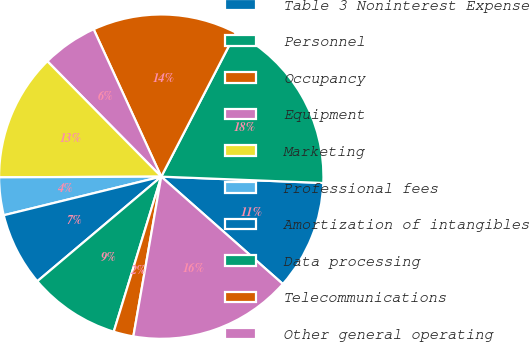<chart> <loc_0><loc_0><loc_500><loc_500><pie_chart><fcel>Table 3 Noninterest Expense<fcel>Personnel<fcel>Occupancy<fcel>Equipment<fcel>Marketing<fcel>Professional fees<fcel>Amortization of intangibles<fcel>Data processing<fcel>Telecommunications<fcel>Other general operating<nl><fcel>10.89%<fcel>18.02%<fcel>14.45%<fcel>5.55%<fcel>12.67%<fcel>3.76%<fcel>7.33%<fcel>9.11%<fcel>1.98%<fcel>16.24%<nl></chart> 